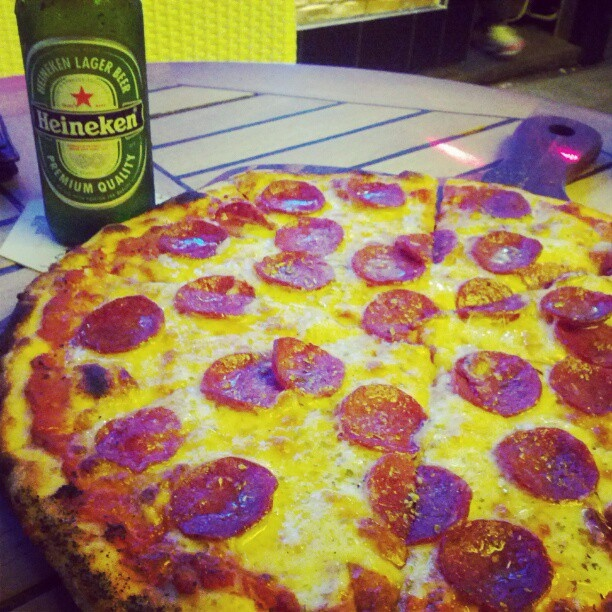Describe the objects in this image and their specific colors. I can see dining table in khaki, darkgray, beige, brown, and gold tones, pizza in khaki, brown, and gold tones, bottle in khaki, black, darkgreen, and olive tones, donut in khaki, violet, brown, and darkgray tones, and donut in khaki, brown, gold, and purple tones in this image. 